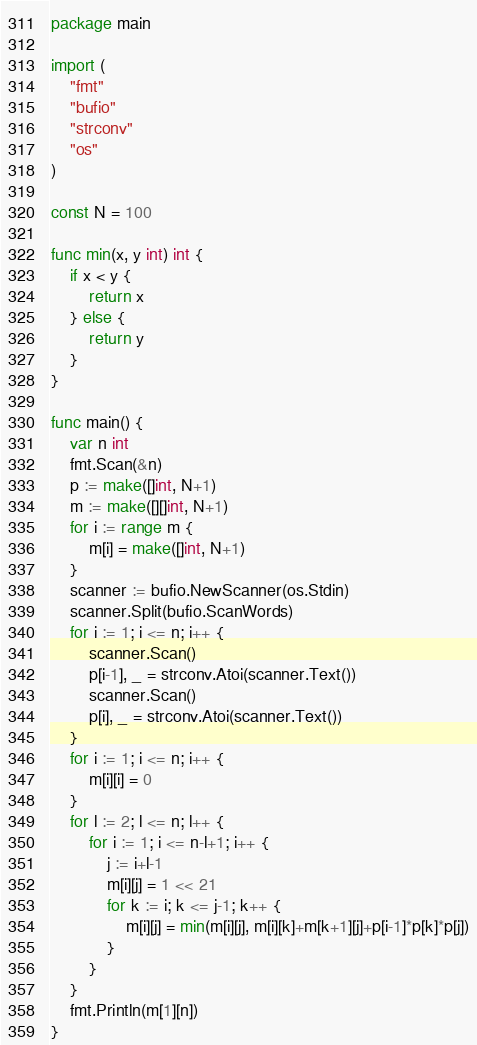Convert code to text. <code><loc_0><loc_0><loc_500><loc_500><_Go_>package main

import (
	"fmt"
	"bufio"
	"strconv"
	"os"
)

const N = 100

func min(x, y int) int {
	if x < y {
		return x
	} else {
		return y
	}
}

func main() {
	var n int
	fmt.Scan(&n)
	p := make([]int, N+1)
	m := make([][]int, N+1)
	for i := range m {
		m[i] = make([]int, N+1)
	}
	scanner := bufio.NewScanner(os.Stdin)
	scanner.Split(bufio.ScanWords)
	for i := 1; i <= n; i++ {
		scanner.Scan()
		p[i-1], _ = strconv.Atoi(scanner.Text())
		scanner.Scan()
		p[i], _ = strconv.Atoi(scanner.Text())
	}
	for i := 1; i <= n; i++ {
		m[i][i] = 0
	}
	for l := 2; l <= n; l++ {
		for i := 1; i <= n-l+1; i++ {
			j := i+l-1
			m[i][j] = 1 << 21
			for k := i; k <= j-1; k++ {
				m[i][j] = min(m[i][j], m[i][k]+m[k+1][j]+p[i-1]*p[k]*p[j])
			}
		}
	}
	fmt.Println(m[1][n])
}
</code> 